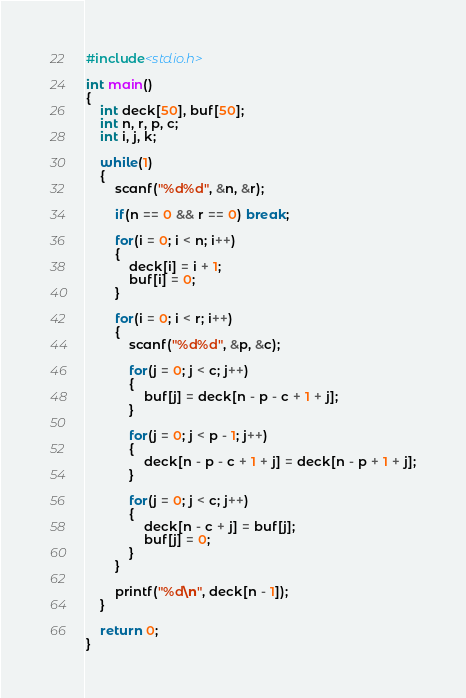<code> <loc_0><loc_0><loc_500><loc_500><_C_>#include<stdio.h>

int main()
{
	int deck[50], buf[50];
	int n, r, p, c;
	int i, j, k;
	
	while(1)
	{
		scanf("%d%d", &n, &r);
		
		if(n == 0 && r == 0) break;
		
		for(i = 0; i < n; i++)
		{
			deck[i] = i + 1;
			buf[i] = 0;
		}
		
		for(i = 0; i < r; i++)
		{
			scanf("%d%d", &p, &c);
			
			for(j = 0; j < c; j++)
			{
				buf[j] = deck[n - p - c + 1 + j];
			}
			
			for(j = 0; j < p - 1; j++)
			{
				deck[n - p - c + 1 + j] = deck[n - p + 1 + j];
			}
			
			for(j = 0; j < c; j++)
			{
				deck[n - c + j] = buf[j];
				buf[j] = 0;
			}
		}
		
		printf("%d\n", deck[n - 1]);
	}
	
	return 0;
}</code> 